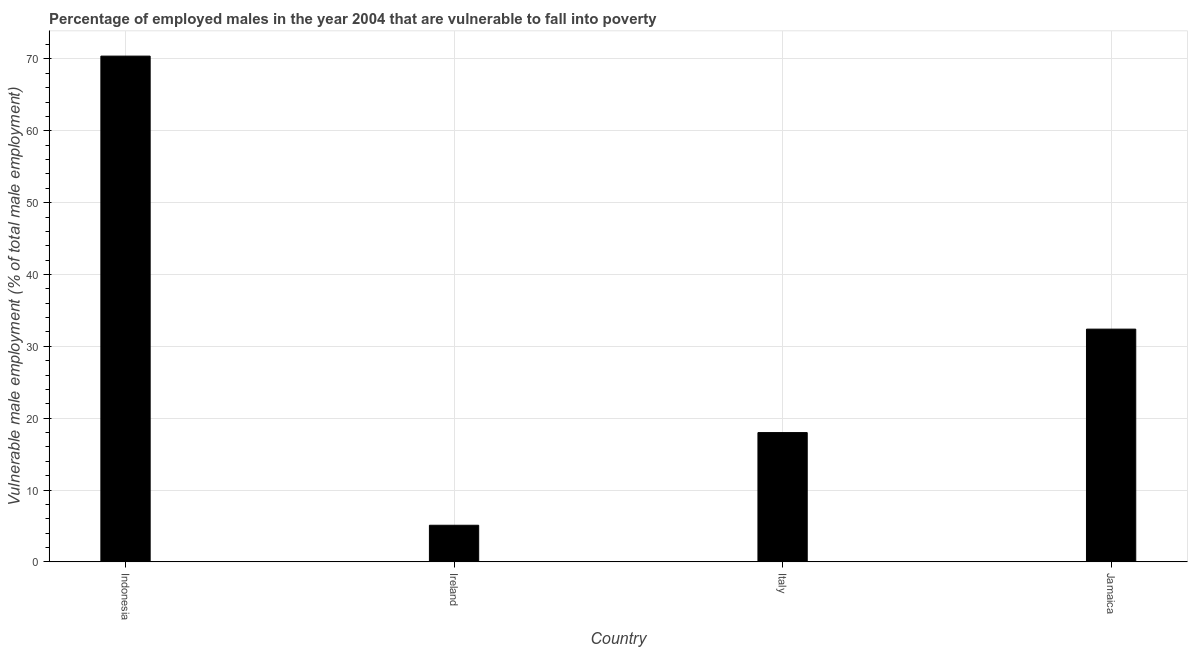What is the title of the graph?
Offer a very short reply. Percentage of employed males in the year 2004 that are vulnerable to fall into poverty. What is the label or title of the X-axis?
Make the answer very short. Country. What is the label or title of the Y-axis?
Make the answer very short. Vulnerable male employment (% of total male employment). What is the percentage of employed males who are vulnerable to fall into poverty in Indonesia?
Your answer should be compact. 70.4. Across all countries, what is the maximum percentage of employed males who are vulnerable to fall into poverty?
Your answer should be very brief. 70.4. Across all countries, what is the minimum percentage of employed males who are vulnerable to fall into poverty?
Ensure brevity in your answer.  5.1. In which country was the percentage of employed males who are vulnerable to fall into poverty minimum?
Provide a succinct answer. Ireland. What is the sum of the percentage of employed males who are vulnerable to fall into poverty?
Ensure brevity in your answer.  125.9. What is the average percentage of employed males who are vulnerable to fall into poverty per country?
Give a very brief answer. 31.48. What is the median percentage of employed males who are vulnerable to fall into poverty?
Your answer should be compact. 25.2. In how many countries, is the percentage of employed males who are vulnerable to fall into poverty greater than 24 %?
Your response must be concise. 2. What is the ratio of the percentage of employed males who are vulnerable to fall into poverty in Italy to that in Jamaica?
Ensure brevity in your answer.  0.56. Is the difference between the percentage of employed males who are vulnerable to fall into poverty in Indonesia and Jamaica greater than the difference between any two countries?
Offer a terse response. No. Is the sum of the percentage of employed males who are vulnerable to fall into poverty in Italy and Jamaica greater than the maximum percentage of employed males who are vulnerable to fall into poverty across all countries?
Offer a terse response. No. What is the difference between the highest and the lowest percentage of employed males who are vulnerable to fall into poverty?
Your answer should be very brief. 65.3. How many bars are there?
Make the answer very short. 4. Are all the bars in the graph horizontal?
Your answer should be very brief. No. How many countries are there in the graph?
Your answer should be compact. 4. What is the difference between two consecutive major ticks on the Y-axis?
Offer a terse response. 10. Are the values on the major ticks of Y-axis written in scientific E-notation?
Offer a terse response. No. What is the Vulnerable male employment (% of total male employment) of Indonesia?
Make the answer very short. 70.4. What is the Vulnerable male employment (% of total male employment) of Ireland?
Offer a terse response. 5.1. What is the Vulnerable male employment (% of total male employment) of Jamaica?
Keep it short and to the point. 32.4. What is the difference between the Vulnerable male employment (% of total male employment) in Indonesia and Ireland?
Your answer should be compact. 65.3. What is the difference between the Vulnerable male employment (% of total male employment) in Indonesia and Italy?
Offer a very short reply. 52.4. What is the difference between the Vulnerable male employment (% of total male employment) in Indonesia and Jamaica?
Offer a very short reply. 38. What is the difference between the Vulnerable male employment (% of total male employment) in Ireland and Italy?
Your answer should be compact. -12.9. What is the difference between the Vulnerable male employment (% of total male employment) in Ireland and Jamaica?
Your response must be concise. -27.3. What is the difference between the Vulnerable male employment (% of total male employment) in Italy and Jamaica?
Offer a terse response. -14.4. What is the ratio of the Vulnerable male employment (% of total male employment) in Indonesia to that in Ireland?
Your response must be concise. 13.8. What is the ratio of the Vulnerable male employment (% of total male employment) in Indonesia to that in Italy?
Offer a terse response. 3.91. What is the ratio of the Vulnerable male employment (% of total male employment) in Indonesia to that in Jamaica?
Ensure brevity in your answer.  2.17. What is the ratio of the Vulnerable male employment (% of total male employment) in Ireland to that in Italy?
Ensure brevity in your answer.  0.28. What is the ratio of the Vulnerable male employment (% of total male employment) in Ireland to that in Jamaica?
Provide a short and direct response. 0.16. What is the ratio of the Vulnerable male employment (% of total male employment) in Italy to that in Jamaica?
Give a very brief answer. 0.56. 